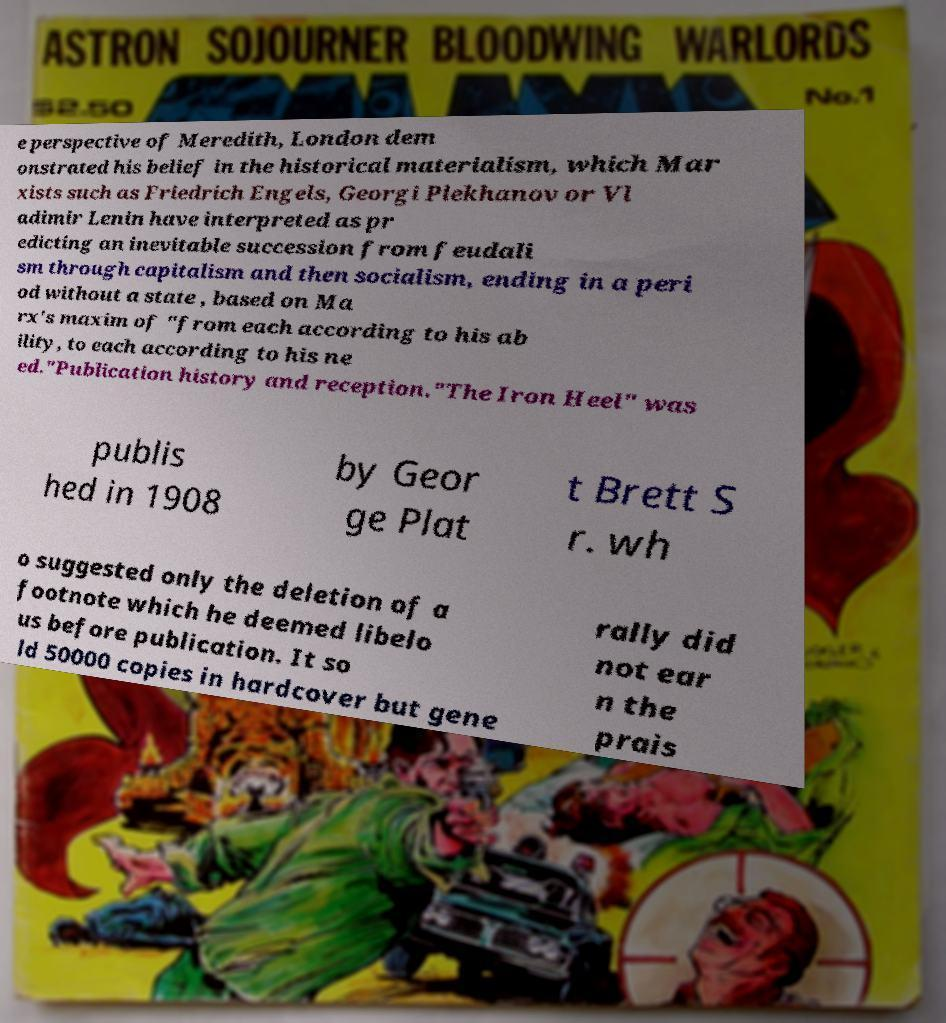There's text embedded in this image that I need extracted. Can you transcribe it verbatim? e perspective of Meredith, London dem onstrated his belief in the historical materialism, which Mar xists such as Friedrich Engels, Georgi Plekhanov or Vl adimir Lenin have interpreted as pr edicting an inevitable succession from feudali sm through capitalism and then socialism, ending in a peri od without a state , based on Ma rx's maxim of "from each according to his ab ility, to each according to his ne ed."Publication history and reception."The Iron Heel" was publis hed in 1908 by Geor ge Plat t Brett S r. wh o suggested only the deletion of a footnote which he deemed libelo us before publication. It so ld 50000 copies in hardcover but gene rally did not ear n the prais 